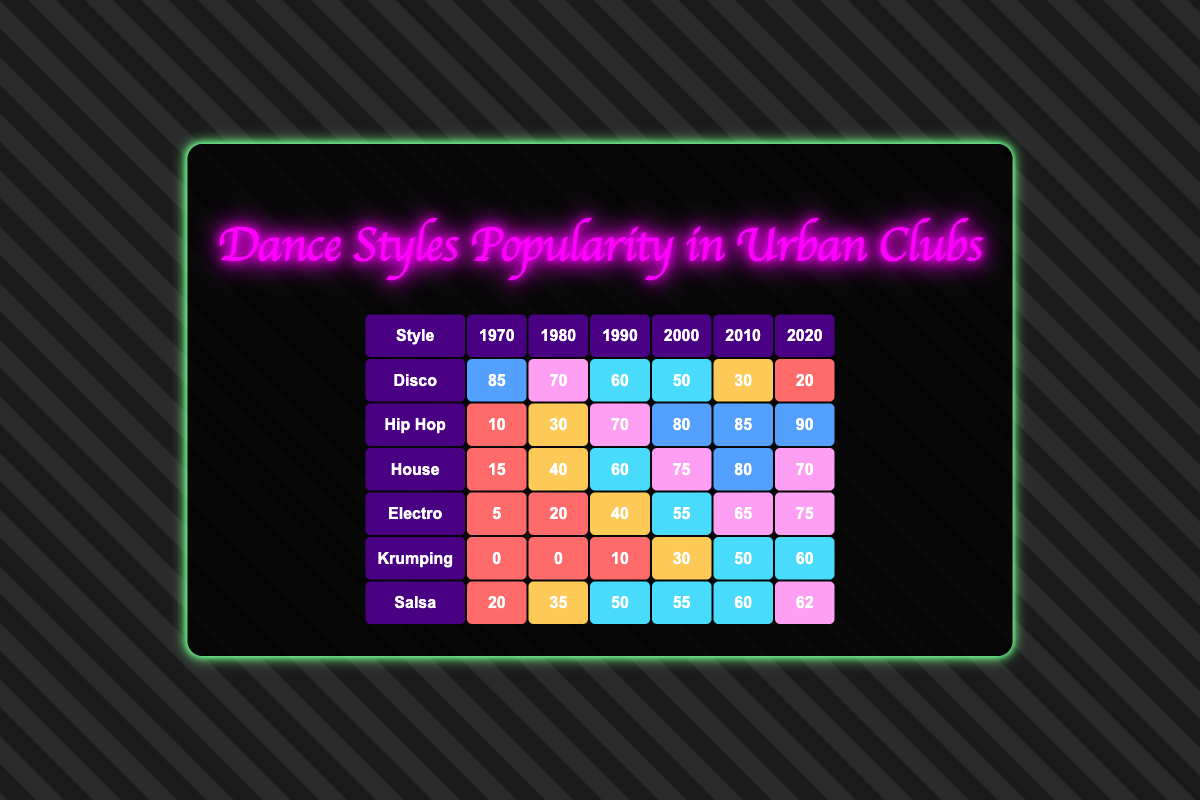What was the popularity of Disco in 1980? The table shows the popularity of Disco in 1980 as 70.
Answer: 70 Which dance style had the highest popularity in 2000? In 2000, Hip Hop had a popularity score of 80, which is the highest compared to other styles in that year.
Answer: Hip Hop What is the average popularity of Salsa over the years? To find the average, sum Salsa's popularity for all years: (20 + 35 + 50 + 55 + 60 + 62) = 282. There are 6 years, so the average is 282/6 = 47.
Answer: 47 Did the popularity of Disco increase from 1970 to 2020? In 1970, Disco had a popularity of 85 and decreased to 20 by 2020, indicating a decline rather than an increase.
Answer: No Which dance style showed the most significant increase in popularity from 1990 to 2000? For each style from 1990 to 2000, the increases are: Hip Hop (70 to 80: +10), House (60 to 75: +15), Electro (40 to 55: +15), Krumping (10 to 30: +20), Salsa (50 to 55: +5). Krumping had the largest increase of 20.
Answer: Krumping What was the popularity difference between House in 2010 and Disco in the same year? House had a popularity of 80 in 2010, while Disco had 30. The difference is calculated as 80 - 30 = 50.
Answer: 50 Which dance style had the lowest popularity in 1970? The table lists Krumping with a popularity score of 0 in 1970, which is lower than all other styles.
Answer: Krumping What is the trend of Electro's popularity from 1970 to 2020? Electro's popularity increased from 5 in 1970 to 75 in 2020, showing a consistent upward trend as indicated by the values in the table.
Answer: Increasing If we compare 2010 and 2020, which dance style maintained the highest popularity? In 2010, Hip Hop had 85 while in 2020, it maintained 90. Therefore, Hip Hop is the dance style that maintained the highest popularity in both years.
Answer: Hip Hop What was the lowest recorded popularity for Krumping across all years? The table indicates that Krumping had a popularity of 0 in both 1970 and 1980, which is the lowest record across all years.
Answer: 0 